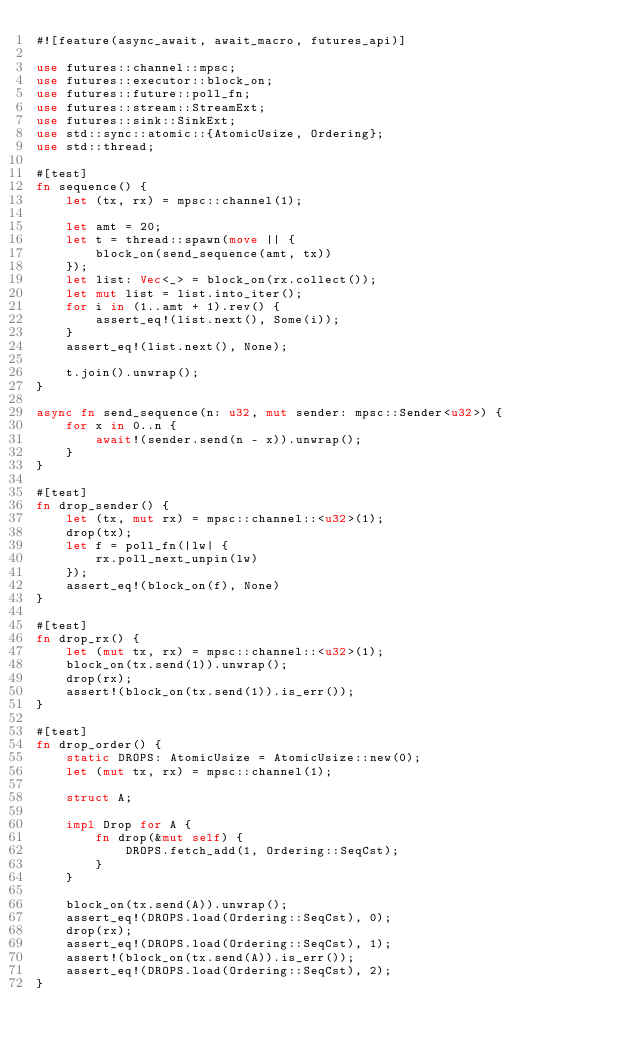<code> <loc_0><loc_0><loc_500><loc_500><_Rust_>#![feature(async_await, await_macro, futures_api)]

use futures::channel::mpsc;
use futures::executor::block_on;
use futures::future::poll_fn;
use futures::stream::StreamExt;
use futures::sink::SinkExt;
use std::sync::atomic::{AtomicUsize, Ordering};
use std::thread;

#[test]
fn sequence() {
    let (tx, rx) = mpsc::channel(1);

    let amt = 20;
    let t = thread::spawn(move || {
        block_on(send_sequence(amt, tx))
    });
    let list: Vec<_> = block_on(rx.collect());
    let mut list = list.into_iter();
    for i in (1..amt + 1).rev() {
        assert_eq!(list.next(), Some(i));
    }
    assert_eq!(list.next(), None);

    t.join().unwrap();
}

async fn send_sequence(n: u32, mut sender: mpsc::Sender<u32>) {
    for x in 0..n {
        await!(sender.send(n - x)).unwrap();
    }
}

#[test]
fn drop_sender() {
    let (tx, mut rx) = mpsc::channel::<u32>(1);
    drop(tx);
    let f = poll_fn(|lw| {
        rx.poll_next_unpin(lw)
    });
    assert_eq!(block_on(f), None)
}

#[test]
fn drop_rx() {
    let (mut tx, rx) = mpsc::channel::<u32>(1);
    block_on(tx.send(1)).unwrap();
    drop(rx);
    assert!(block_on(tx.send(1)).is_err());
}

#[test]
fn drop_order() {
    static DROPS: AtomicUsize = AtomicUsize::new(0);
    let (mut tx, rx) = mpsc::channel(1);

    struct A;

    impl Drop for A {
        fn drop(&mut self) {
            DROPS.fetch_add(1, Ordering::SeqCst);
        }
    }

    block_on(tx.send(A)).unwrap();
    assert_eq!(DROPS.load(Ordering::SeqCst), 0);
    drop(rx);
    assert_eq!(DROPS.load(Ordering::SeqCst), 1);
    assert!(block_on(tx.send(A)).is_err());
    assert_eq!(DROPS.load(Ordering::SeqCst), 2);
}
</code> 